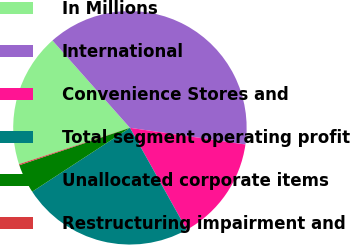Convert chart to OTSL. <chart><loc_0><loc_0><loc_500><loc_500><pie_chart><fcel>In Millions<fcel>International<fcel>Convenience Stores and<fcel>Total segment operating profit<fcel>Unallocated corporate items<fcel>Restructuring impairment and<nl><fcel>18.5%<fcel>38.83%<fcel>14.63%<fcel>23.88%<fcel>4.02%<fcel>0.15%<nl></chart> 